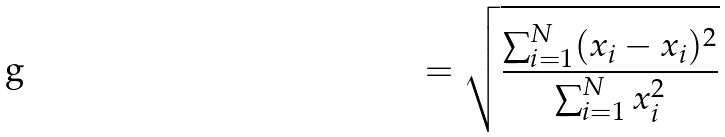<formula> <loc_0><loc_0><loc_500><loc_500>= \sqrt { \frac { \sum _ { i = 1 } ^ { N } ( x _ { i } - x _ { i } ) ^ { 2 } } { \sum _ { i = 1 } ^ { N } x _ { i } ^ { 2 } } }</formula> 